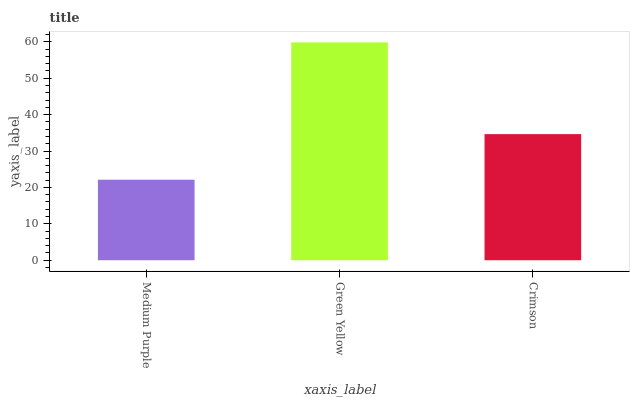Is Medium Purple the minimum?
Answer yes or no. Yes. Is Green Yellow the maximum?
Answer yes or no. Yes. Is Crimson the minimum?
Answer yes or no. No. Is Crimson the maximum?
Answer yes or no. No. Is Green Yellow greater than Crimson?
Answer yes or no. Yes. Is Crimson less than Green Yellow?
Answer yes or no. Yes. Is Crimson greater than Green Yellow?
Answer yes or no. No. Is Green Yellow less than Crimson?
Answer yes or no. No. Is Crimson the high median?
Answer yes or no. Yes. Is Crimson the low median?
Answer yes or no. Yes. Is Green Yellow the high median?
Answer yes or no. No. Is Medium Purple the low median?
Answer yes or no. No. 